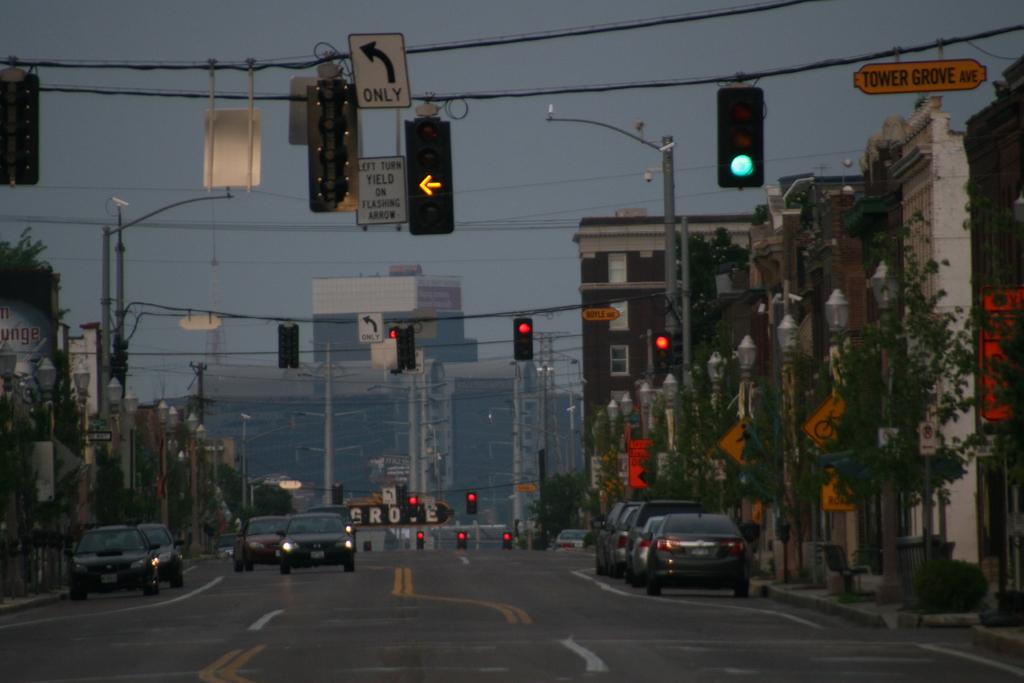What is the name of this street?
Provide a succinct answer. Tower grove ave. 